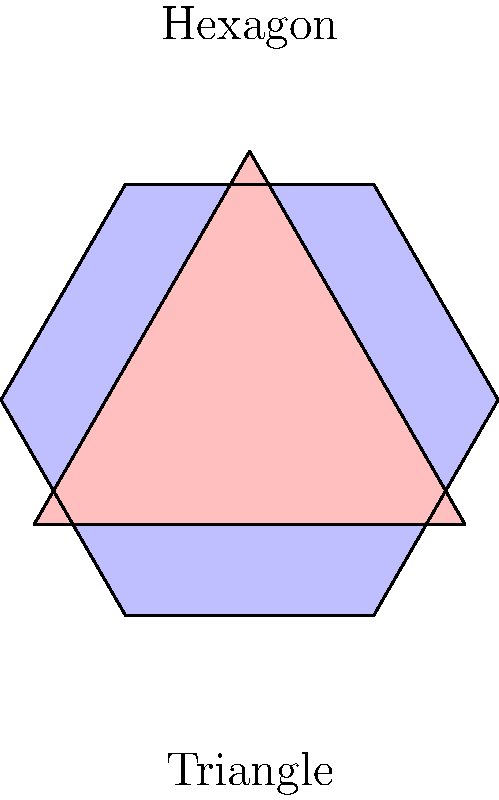In the realm of poetic structure and geometric symmetry, consider a hexagon and an equilateral triangle as shown. If the number of lines in a poem's stanza is represented by the number of rotational symmetries of these shapes, how many more lines would a "hexagon stanza" have compared to a "triangle stanza"? To solve this problem, we need to consider the rotational symmetries of both shapes:

1. Hexagon:
   - A regular hexagon has 6 rotational symmetries (60°, 120°, 180°, 240°, 300°, 360°).
   - This corresponds to 6 lines in a "hexagon stanza".

2. Equilateral Triangle:
   - An equilateral triangle has 3 rotational symmetries (120°, 240°, 360°).
   - This corresponds to 3 lines in a "triangle stanza".

3. Difference in lines:
   - Hexagon stanza lines: 6
   - Triangle stanza lines: 3
   - Difference: 6 - 3 = 3

Therefore, a "hexagon stanza" would have 3 more lines than a "triangle stanza".

This mirrors the concept in poetry where different stanza structures can create varying rhythms and symmetries in verse, much like the rotational symmetries in geometric shapes create visual balance.
Answer: 3 lines 